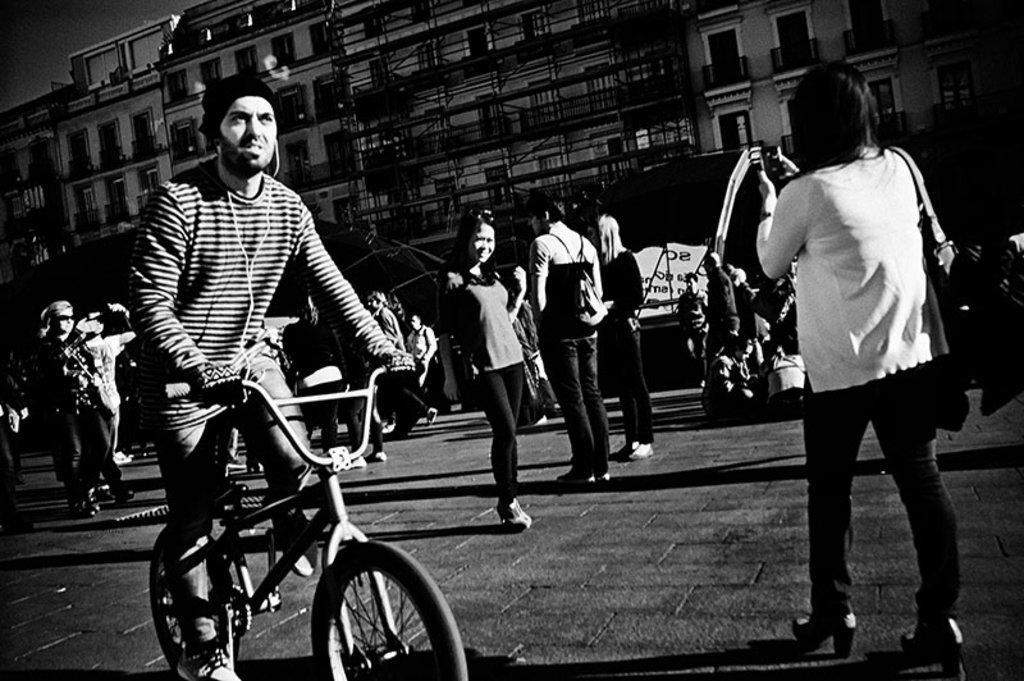How would you summarize this image in a sentence or two? As we can see in the image, there are buildings and few people standing on road. In the front there is a man riding bicycle and on the right side there is a woman holding camera camera in her hand. 